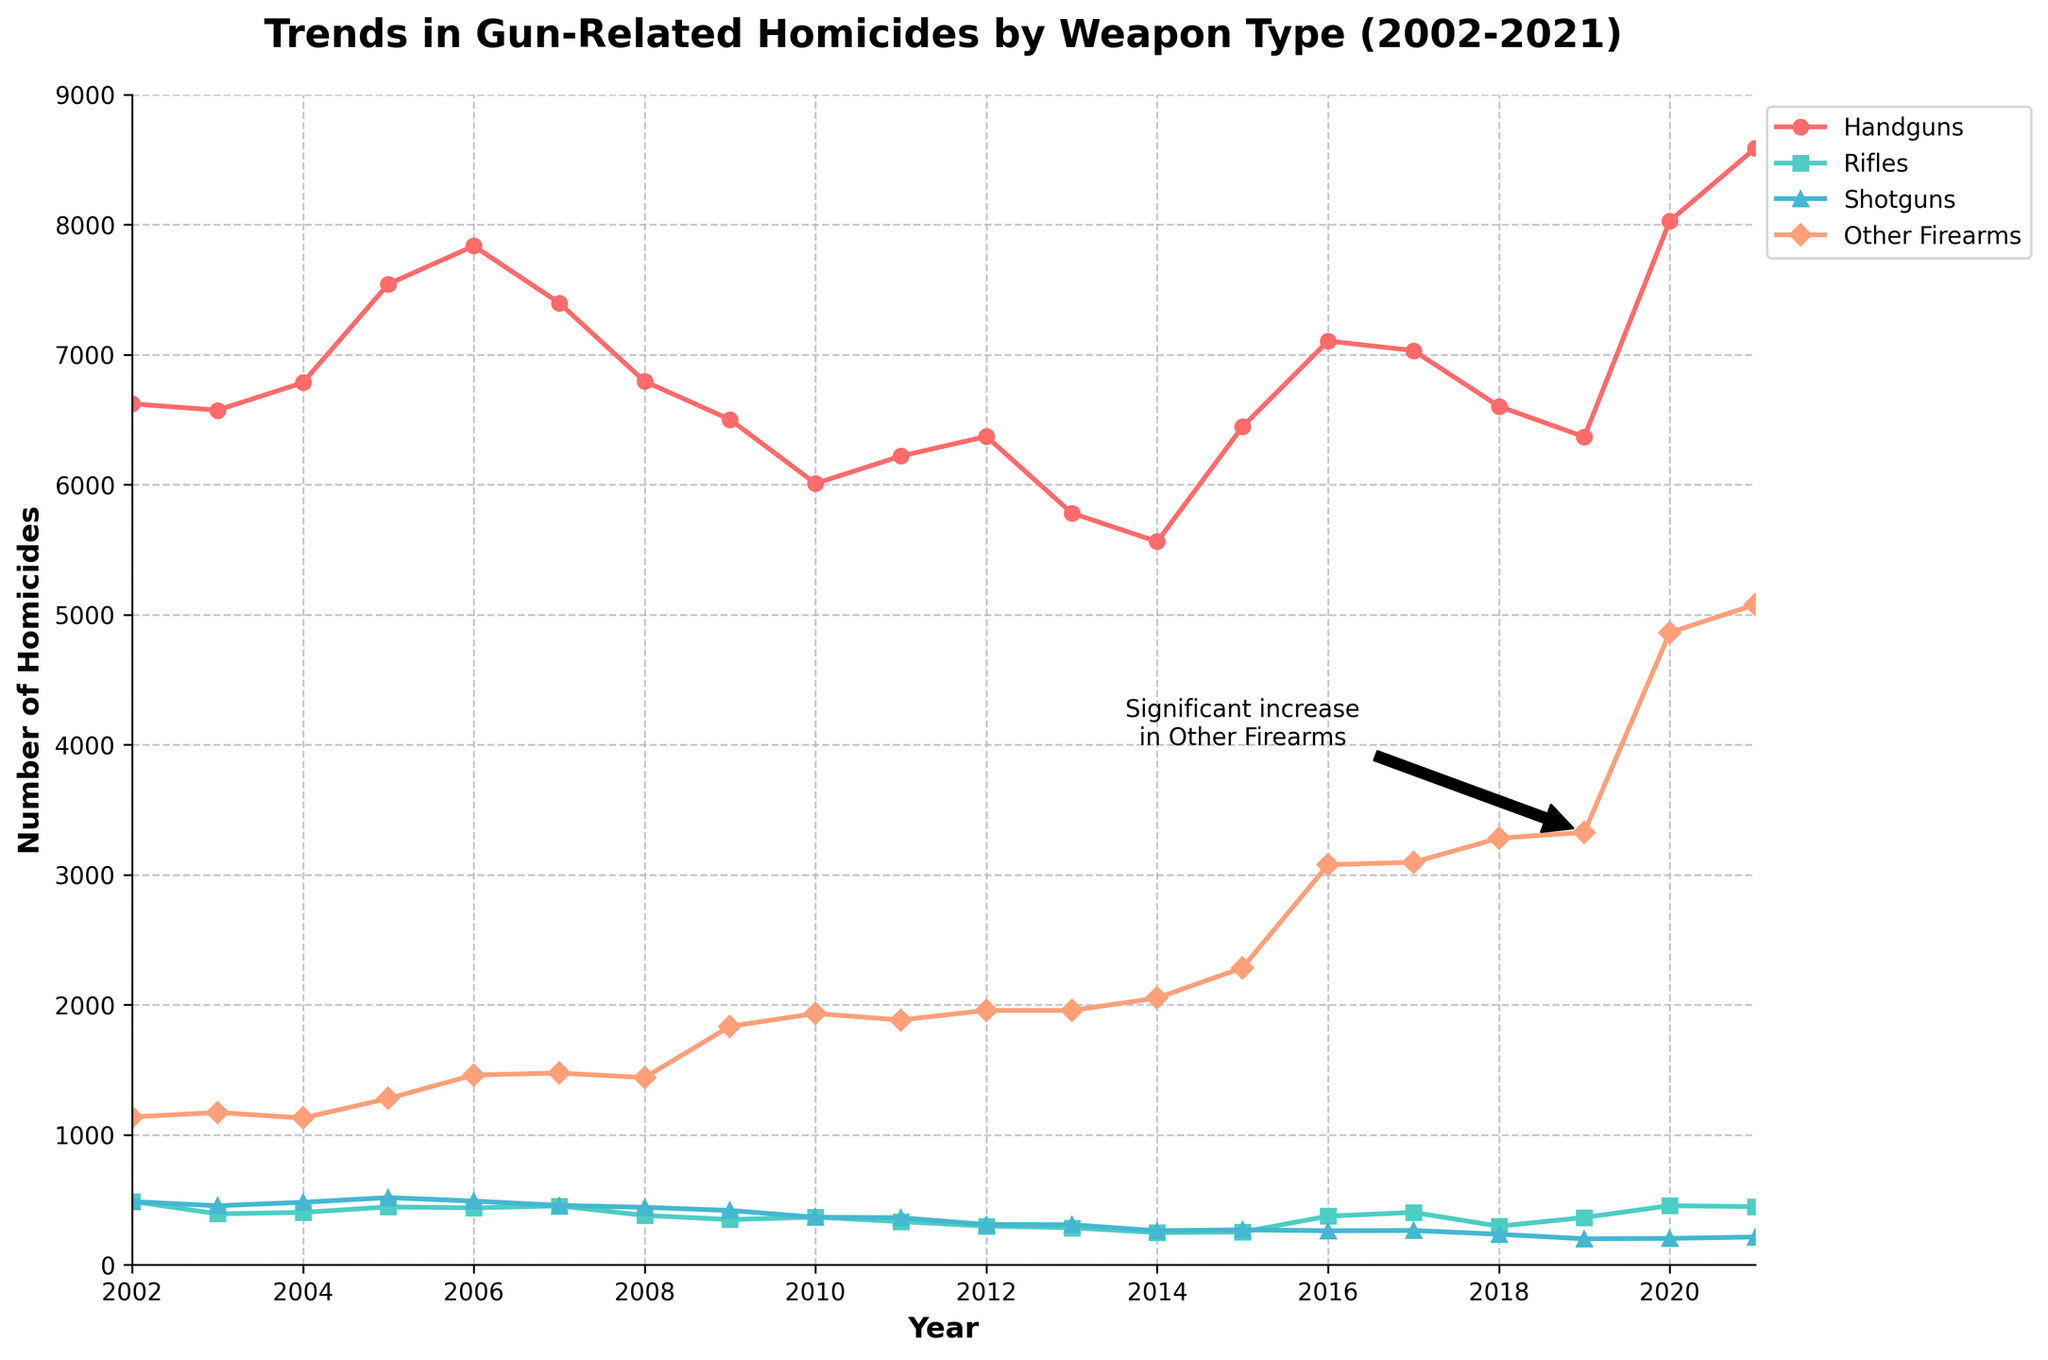How did the number of homicides by handguns change from 2002 to 2021? First, check the data for handgun-related homicides in 2002, which is 6622. Then, check the data for 2021, which is 8587. The change is calculated as 8587 - 6622.
Answer: 1965 Which weapon type saw the highest increase in the number of homicides from 2002 to 2021? Compare the data for all weapon types in 2002 and 2021. Handguns increased from 6622 to 8587, Rifles decreased from 488 to 447, Shotguns decreased from 486 to 214, and Other Firearms increased from 1137 to 5078. The greatest increase is 5078 - 1137 for Other Firearms.
Answer: Other Firearms Which year had the highest number of total homicides across all weapon types? Calculate the sum of homicides across all weapon types for each year. The year with the highest sum is 2021, with 8587 (Handguns) + 447 (Rifles) + 214 (Shotguns) + 5078 (Other Firearms) = 14326.
Answer: 2021 What is the trend observed in the number of homicides by other firearms after 2015? From the chart, observe the line representing Other Firearms after 2015. The line shows a steep upward trend from 2285 in 2015 to 5078 in 2021.
Answer: Increasing Compare the number of homicides by shotguns and rifles in 2013. Which weapon type had fewer homicides? Check the values on the chart for 2013. Shotguns had 308 homicides, and Rifles had 285 homicides. Since 285 is less than 308, rifles had fewer homicides.
Answer: Rifles What is the average number of homicides by handguns over the 20-year period? Sum the values for handguns from 2002 to 2021 and then divide by the number of years (20). The sum is 136172. Divide by 20 to get the average: 136172 / 20.
Answer: 6808.6 By how much did the number of homicides by rifles decrease from 2008 to 2014? Check the chart for homicides by rifles in 2008 and 2014. In 2008, there were 380 homicides, and in 2014, there were 248. The decrease is calculated as 380 - 248.
Answer: 132 In what year did handgun-related homicides first exceed 7000? Look at the chart for the handgun line and find the first year where it crosses 7000. This happens in 2005.
Answer: 2005 Between 2009 and 2021, which weapon type experienced the most stable trend in homicide numbers? Analyze the chart lines for the period between 2009 and 2021. Rifles show a relatively stable line with small fluctuations compared to other weapon types.
Answer: Rifles How many more homicides were there by handguns than by other firearms in 2018? Refer to the data for 2018: Handguns had 6603 homicides, and Other Firearms had 3281. Calculate the difference: 6603 - 3281.
Answer: 3322 